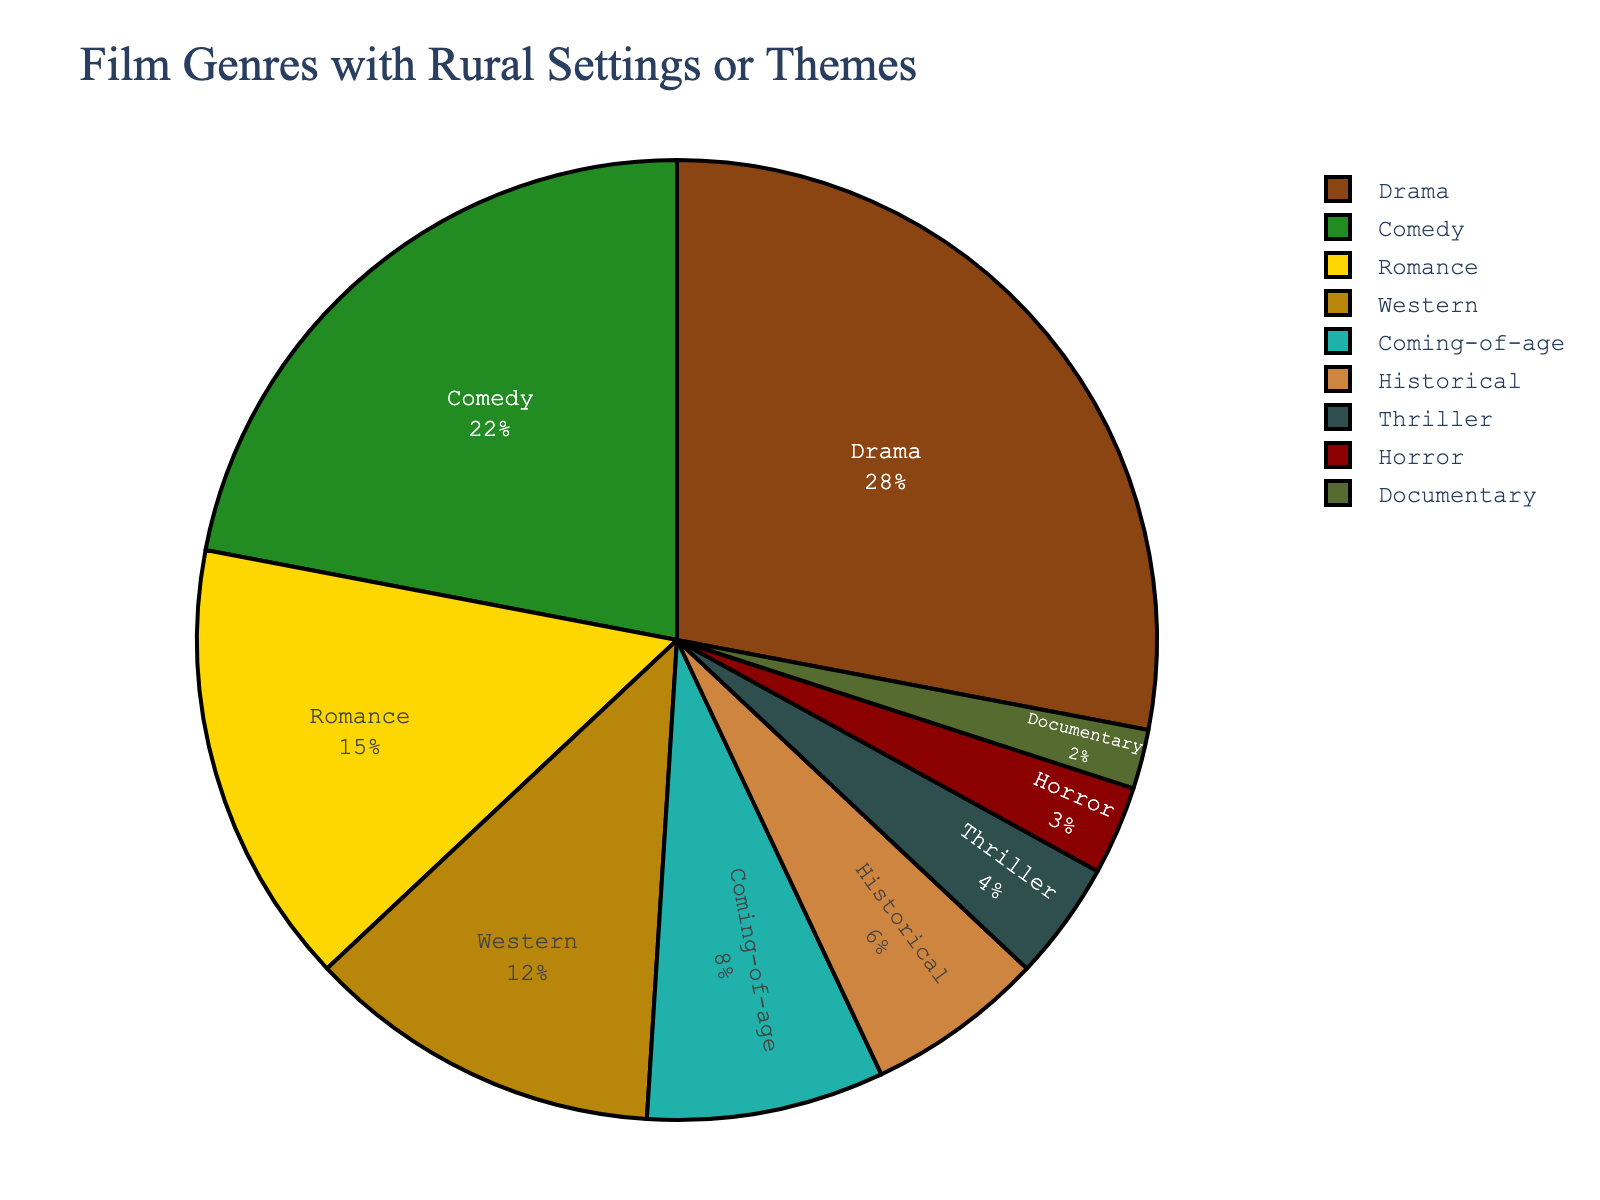Which genre has the highest percentage in the pie chart? Look for the largest segment in the pie chart, the one that occupies the most space.
Answer: Drama Which two genres have equal percentages? Identify the two segments that are the same size in the pie chart.
Answer: Thriller and Horror What's the total percentage for the genres with the lowest percentage? Find the segments with the smallest values: Documentary (2%); sum these values.
Answer: 2% How does the percentage of Drama compare to that of Horror? Compare the sizes of the Drama and Horror segments. Drama is 28%, and Horror is 3%. Drama is significantly larger.
Answer: Drama is larger What's the combined percentage of Romance and Western genres? Add the percentages for Romance (15%) and Western (12%).
Answer: 27% Which color represents the Documentary genre? Match the color of the smallest segment to the legend in the pie chart.
Answer: Dark green What is the difference in percentage between Comedy and Historical genres? Subtract the percentage of Historical (6%) from the percentage of Comedy (22%).
Answer: 16% Which genre has the third largest percentage? Find the third-largest segment by comparing the sizes of each. Drama is the largest, followed by Comedy, then Romance.
Answer: Romance What percentage do Thriller and Horror genres contribute together? Add the percentages of Thriller (4%) and Horror (3%).
Answer: 7% Which genre is represented by the dark yellow color? Match the color of the segment to the legend in the pie chart.
Answer: Historical 